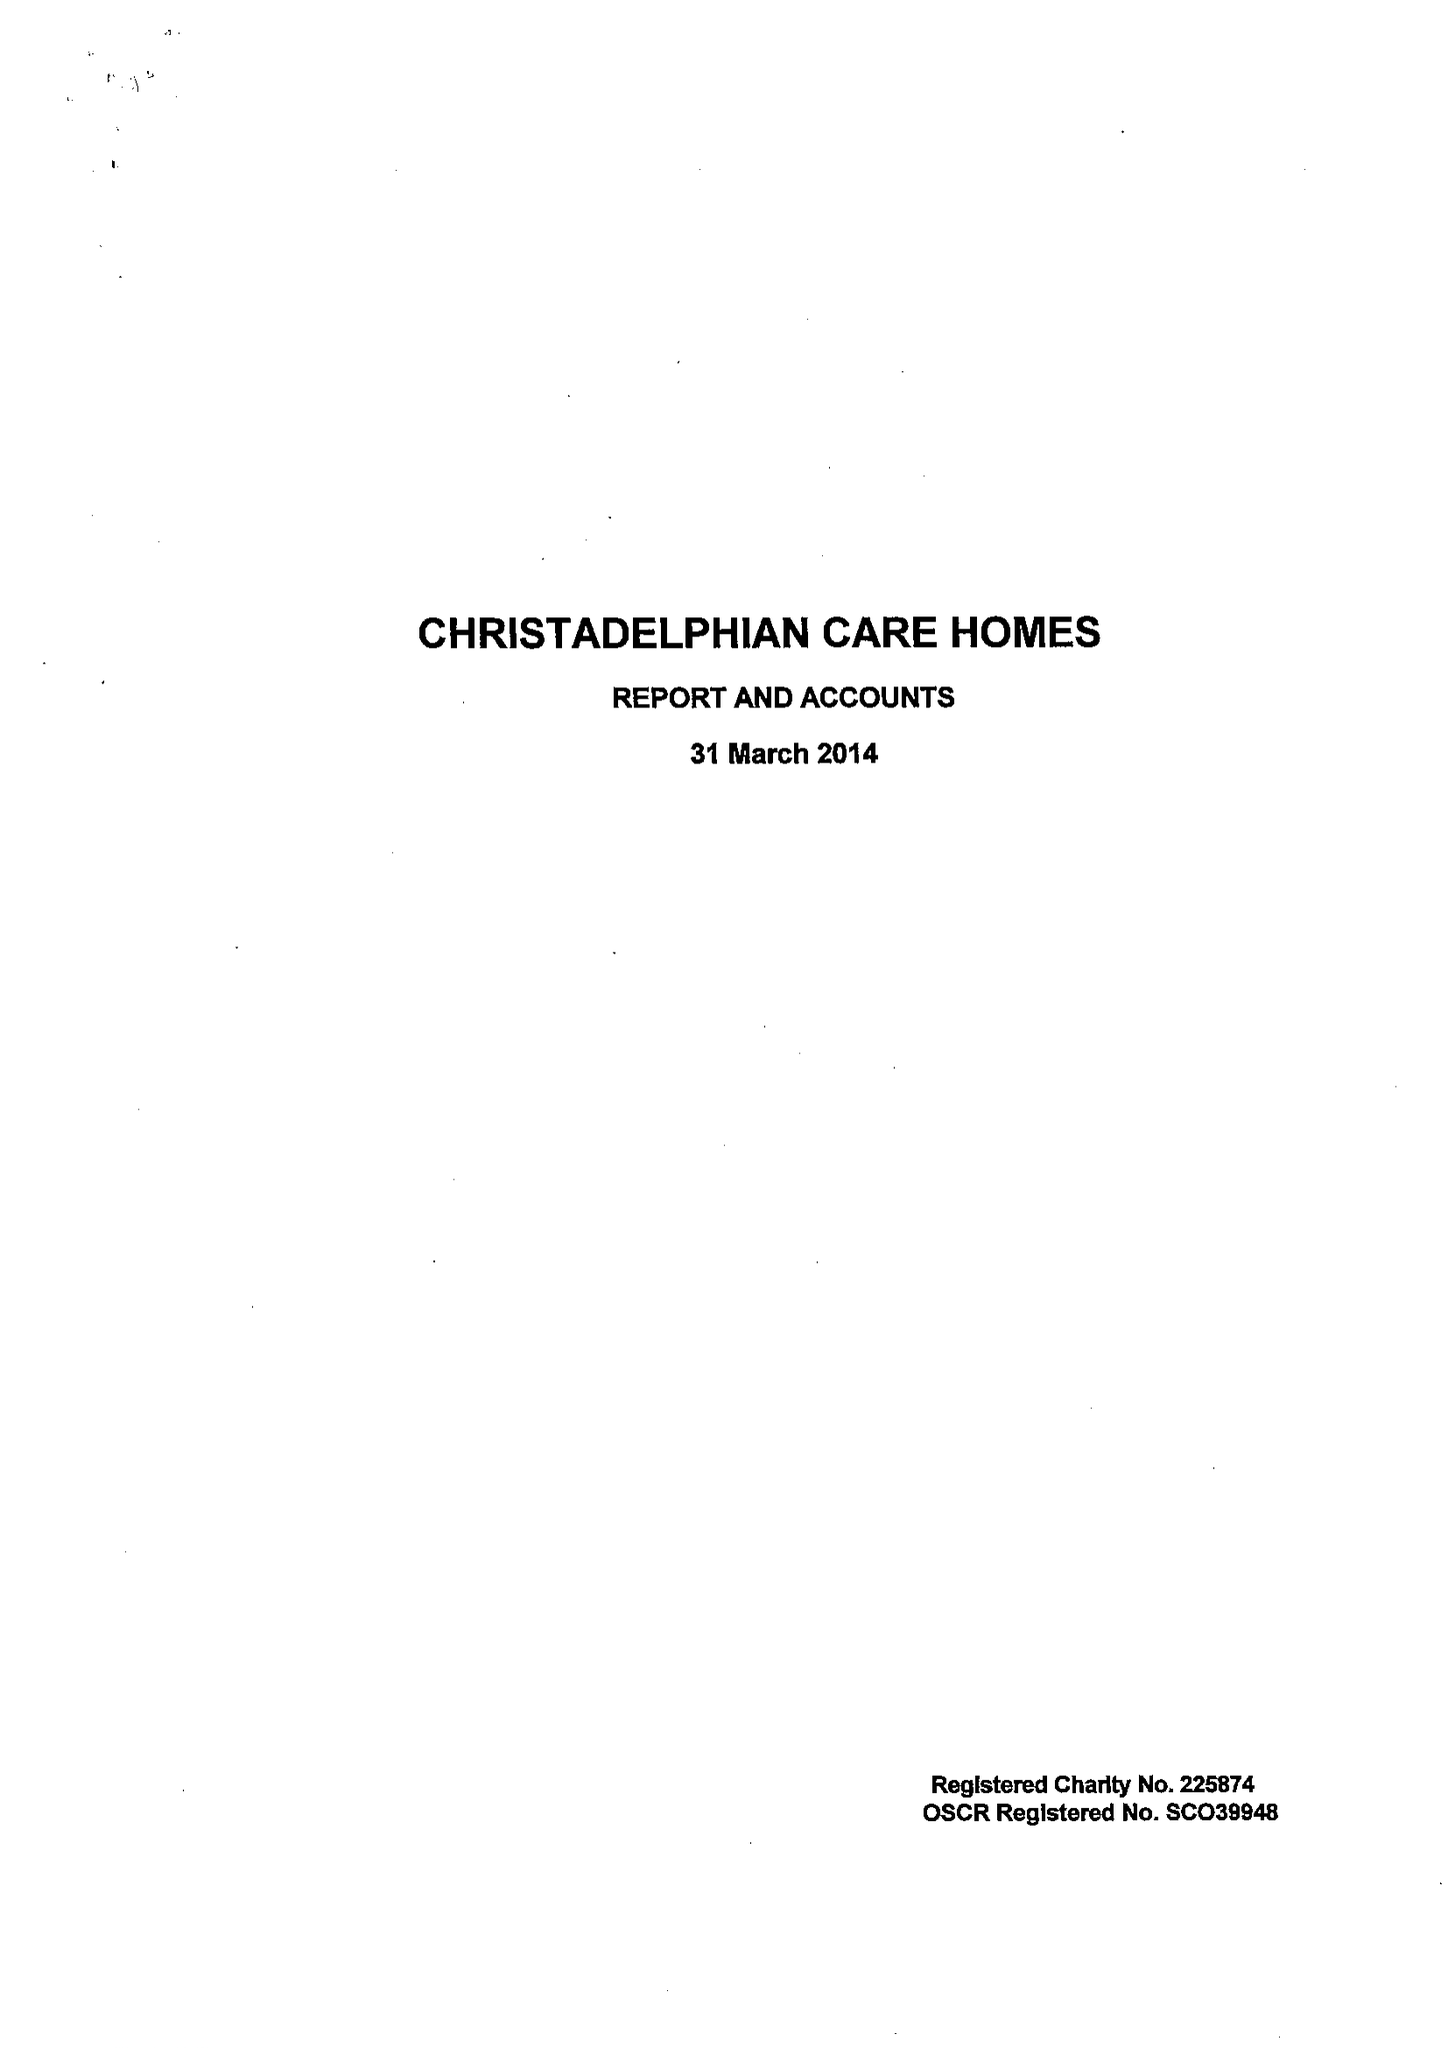What is the value for the address__postcode?
Answer the question using a single word or phrase. B27 6AD 